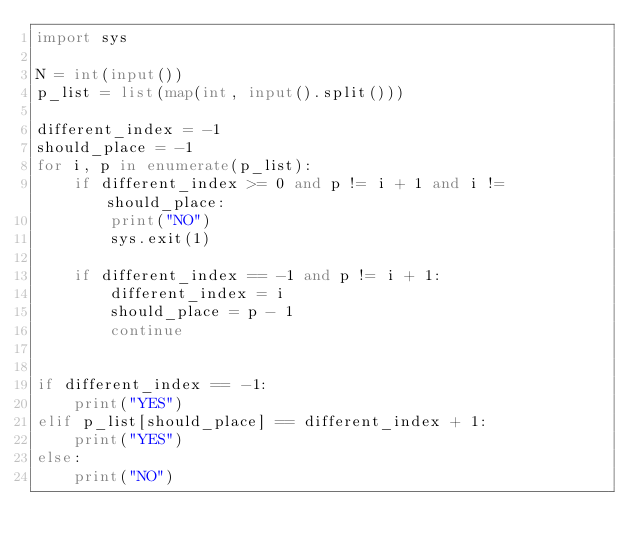Convert code to text. <code><loc_0><loc_0><loc_500><loc_500><_Python_>import sys

N = int(input())
p_list = list(map(int, input().split()))

different_index = -1
should_place = -1
for i, p in enumerate(p_list):
    if different_index >= 0 and p != i + 1 and i != should_place:
        print("NO")
        sys.exit(1)

    if different_index == -1 and p != i + 1:
        different_index = i
        should_place = p - 1
        continue
    

if different_index == -1:
    print("YES")
elif p_list[should_place] == different_index + 1:
    print("YES")
else:
    print("NO")</code> 